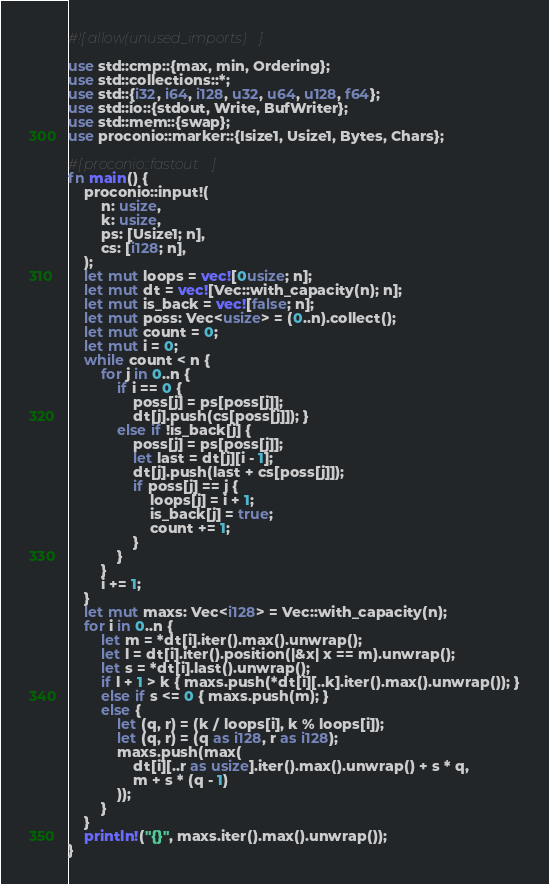Convert code to text. <code><loc_0><loc_0><loc_500><loc_500><_Rust_>#![allow(unused_imports)]

use std::cmp::{max, min, Ordering};
use std::collections::*;
use std::{i32, i64, i128, u32, u64, u128, f64};
use std::io::{stdout, Write, BufWriter};
use std::mem::{swap};
use proconio::marker::{Isize1, Usize1, Bytes, Chars};

#[proconio::fastout]
fn main() {
    proconio::input!(
        n: usize,
        k: usize,
        ps: [Usize1; n],
        cs: [i128; n],
    );
    let mut loops = vec![0usize; n];
    let mut dt = vec![Vec::with_capacity(n); n];
    let mut is_back = vec![false; n];
    let mut poss: Vec<usize> = (0..n).collect();
    let mut count = 0;
    let mut i = 0;
    while count < n {
        for j in 0..n {
            if i == 0 {
                poss[j] = ps[poss[j]];
                dt[j].push(cs[poss[j]]); }
            else if !is_back[j] {
                poss[j] = ps[poss[j]];
                let last = dt[j][i - 1];
                dt[j].push(last + cs[poss[j]]);
                if poss[j] == j {
                    loops[j] = i + 1;
                    is_back[j] = true;
                    count += 1;
                }
            }
        }
        i += 1;
    }
    let mut maxs: Vec<i128> = Vec::with_capacity(n);
    for i in 0..n {
        let m = *dt[i].iter().max().unwrap();
        let l = dt[i].iter().position(|&x| x == m).unwrap();
        let s = *dt[i].last().unwrap();
        if l + 1 > k { maxs.push(*dt[i][..k].iter().max().unwrap()); }
        else if s <= 0 { maxs.push(m); }
        else {
            let (q, r) = (k / loops[i], k % loops[i]);
            let (q, r) = (q as i128, r as i128);
            maxs.push(max(
                dt[i][..r as usize].iter().max().unwrap() + s * q,
                m + s * (q - 1)
            ));
        }
    }
    println!("{}", maxs.iter().max().unwrap());
}
</code> 